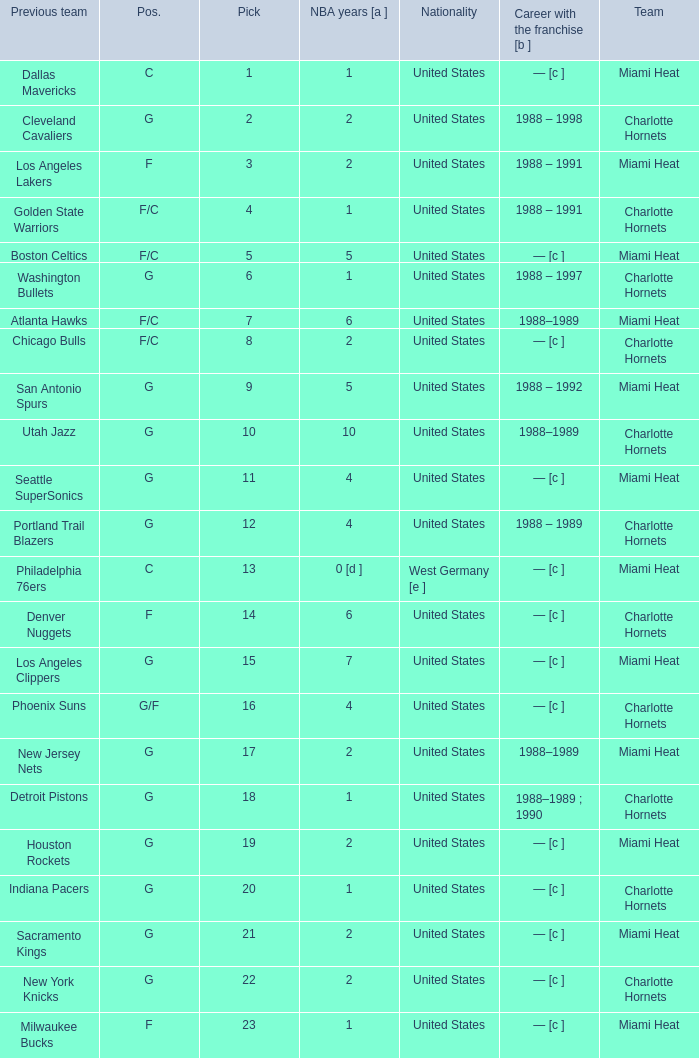How many NBA years did the player from the United States who was previously on the los angeles lakers have? 2.0. 